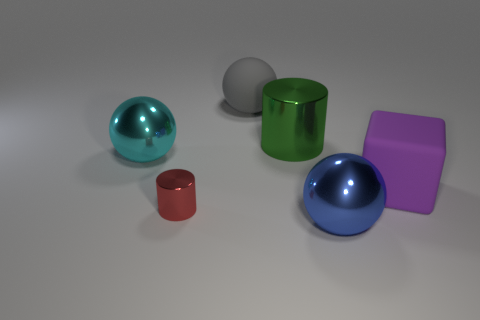Judging by their size, could these objects be held comfortably in the hand? The small red cylinder and the medium-sized spheres would likely fit comfortably in an adult's hands, while the larger green cylinder might require both hands to hold securely due to its size. 